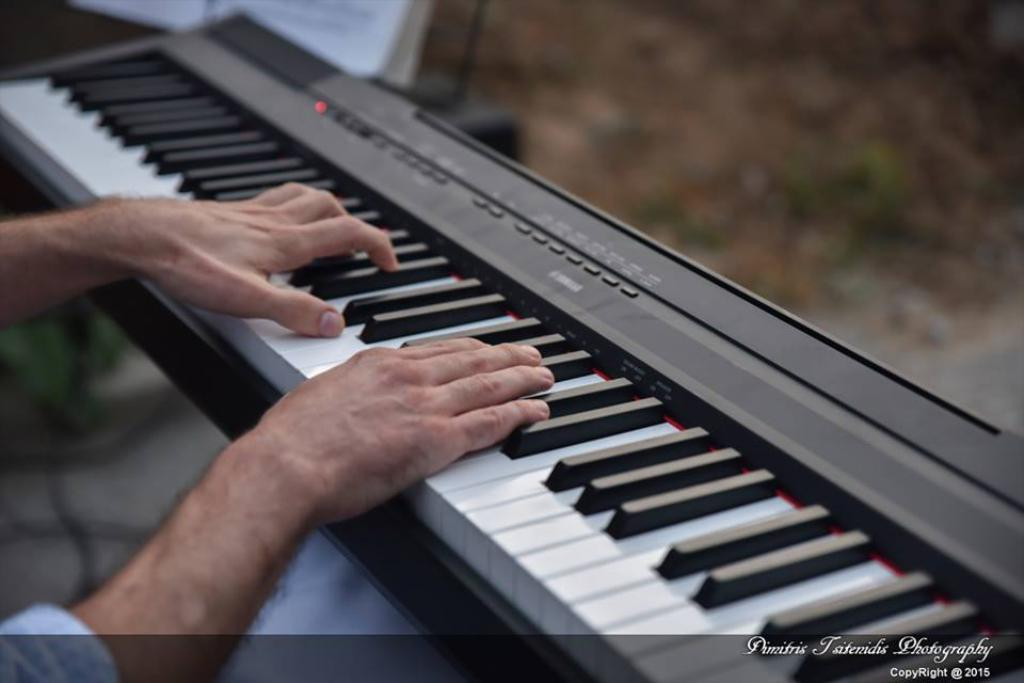What is the main subject of the image? There is a person in the image. What is the person doing in the image? The person is playing a keyboard. What type of wilderness can be seen in the background of the image? There is no wilderness visible in the image; it only shows a person playing a keyboard. How many spiders are crawling on the keyboard in the image? There are no spiders present in the image; it only shows a person playing a keyboard. 